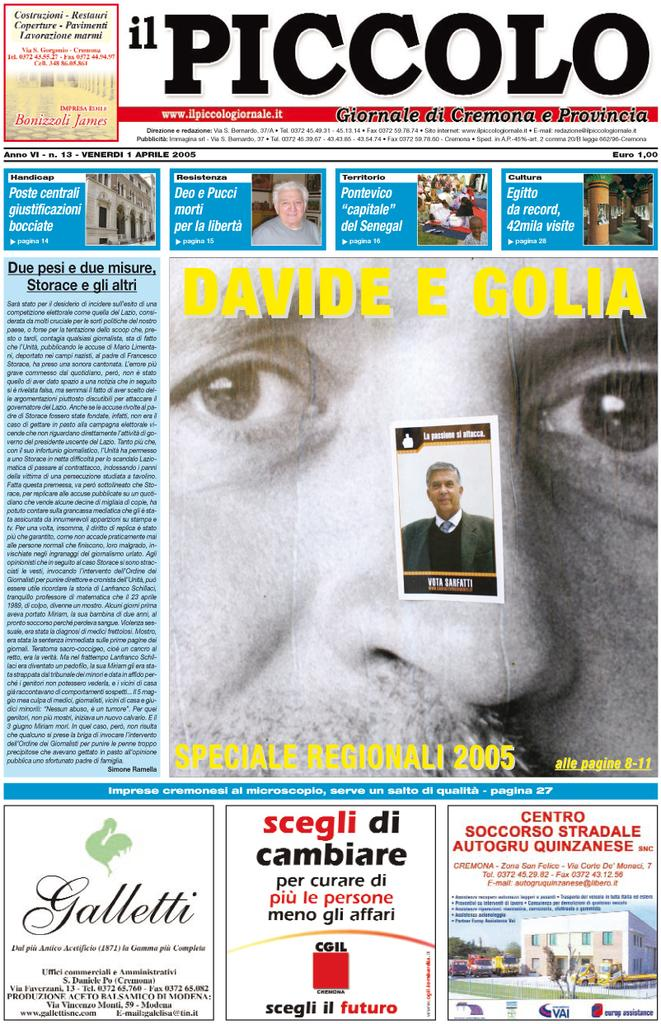What type of visual representation is shown in the image? The image is a poster. What subjects are depicted in the poster? There are people, buildings, vehicles, and objects depicted in the poster. Is there any text present in the poster? Yes, there is text present in the poster. Can you see a church depicted in the poster? There is no church depicted in the poster; it features people, buildings, vehicles, and objects. What type of knife is being used by the people in the poster? There is no knife present in the poster; it only features people, buildings, vehicles, objects, and text. 